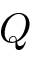<formula> <loc_0><loc_0><loc_500><loc_500>Q</formula> 